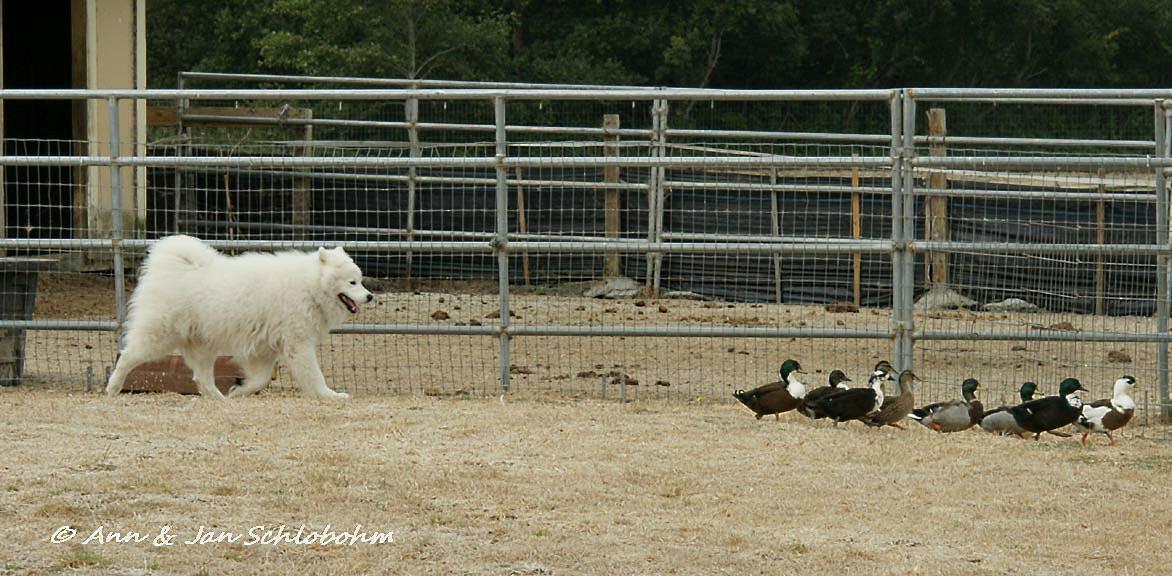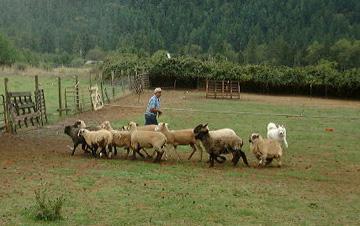The first image is the image on the left, the second image is the image on the right. Evaluate the accuracy of this statement regarding the images: "An image shows a white dog with a flock of ducks.". Is it true? Answer yes or no. Yes. The first image is the image on the left, the second image is the image on the right. Examine the images to the left and right. Is the description "there are exactly three sheep in one of the images" accurate? Answer yes or no. No. 